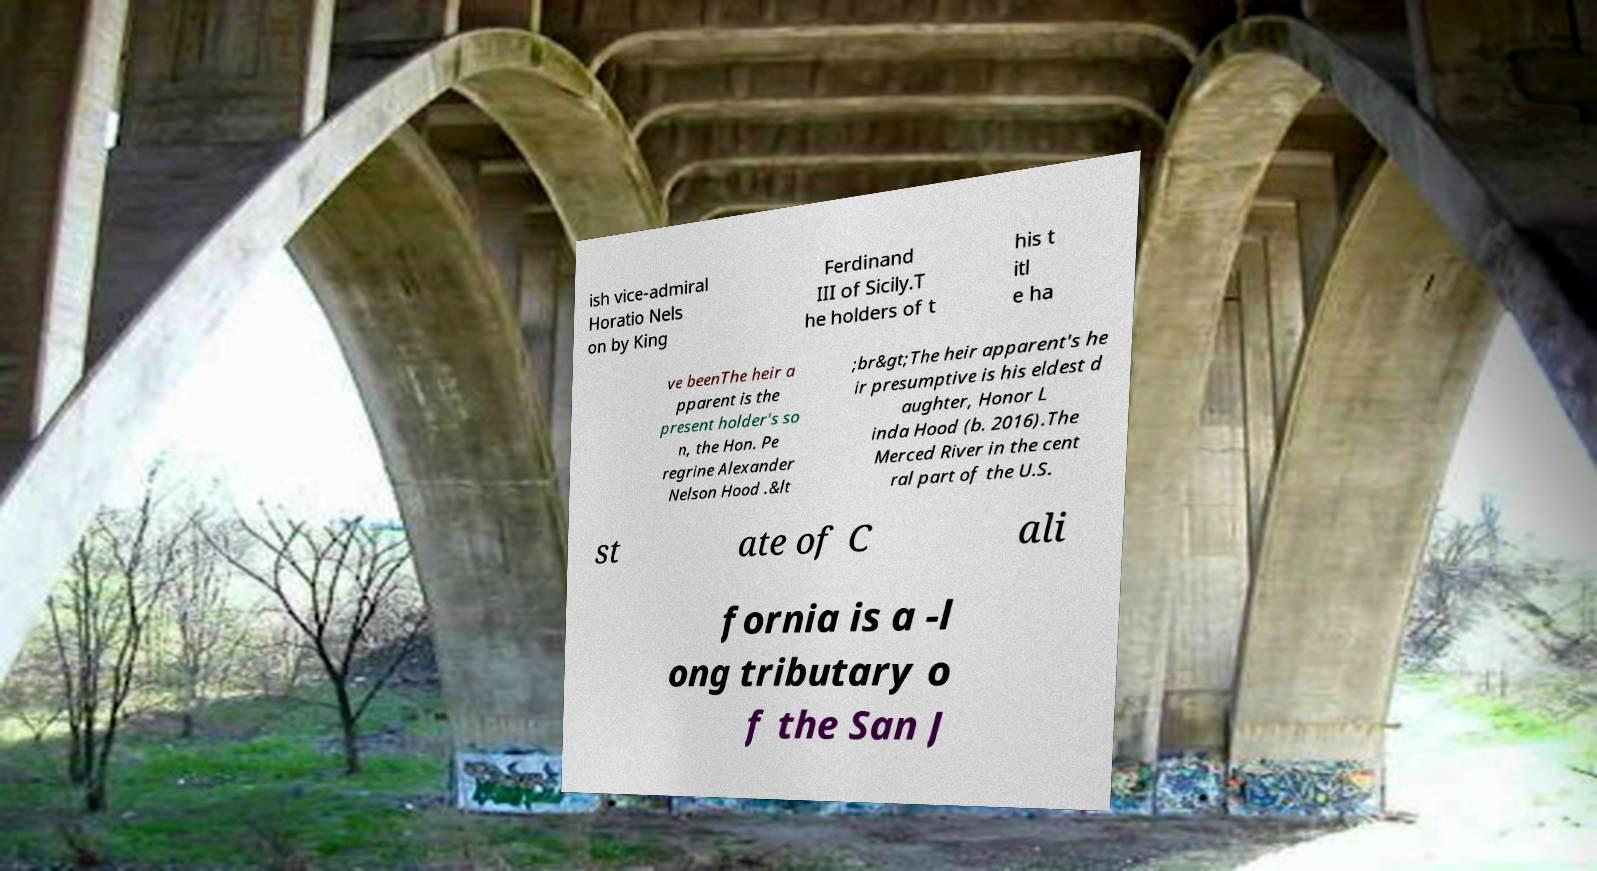Please read and relay the text visible in this image. What does it say? ish vice-admiral Horatio Nels on by King Ferdinand III of Sicily.T he holders of t his t itl e ha ve beenThe heir a pparent is the present holder's so n, the Hon. Pe regrine Alexander Nelson Hood .&lt ;br&gt;The heir apparent's he ir presumptive is his eldest d aughter, Honor L inda Hood (b. 2016).The Merced River in the cent ral part of the U.S. st ate of C ali fornia is a -l ong tributary o f the San J 